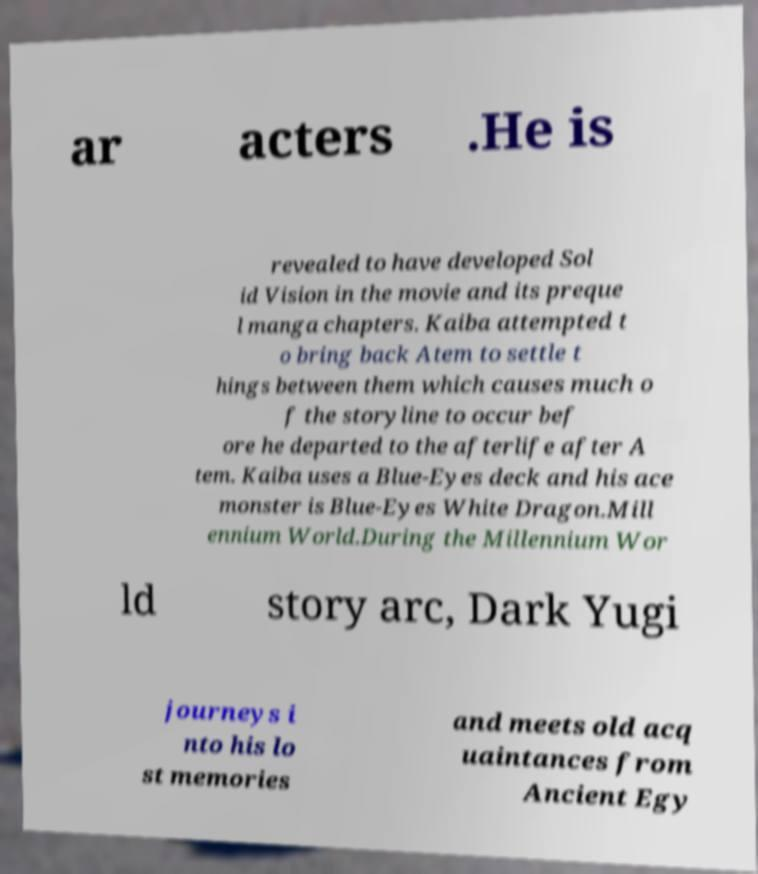Can you read and provide the text displayed in the image?This photo seems to have some interesting text. Can you extract and type it out for me? ar acters .He is revealed to have developed Sol id Vision in the movie and its preque l manga chapters. Kaiba attempted t o bring back Atem to settle t hings between them which causes much o f the storyline to occur bef ore he departed to the afterlife after A tem. Kaiba uses a Blue-Eyes deck and his ace monster is Blue-Eyes White Dragon.Mill ennium World.During the Millennium Wor ld story arc, Dark Yugi journeys i nto his lo st memories and meets old acq uaintances from Ancient Egy 